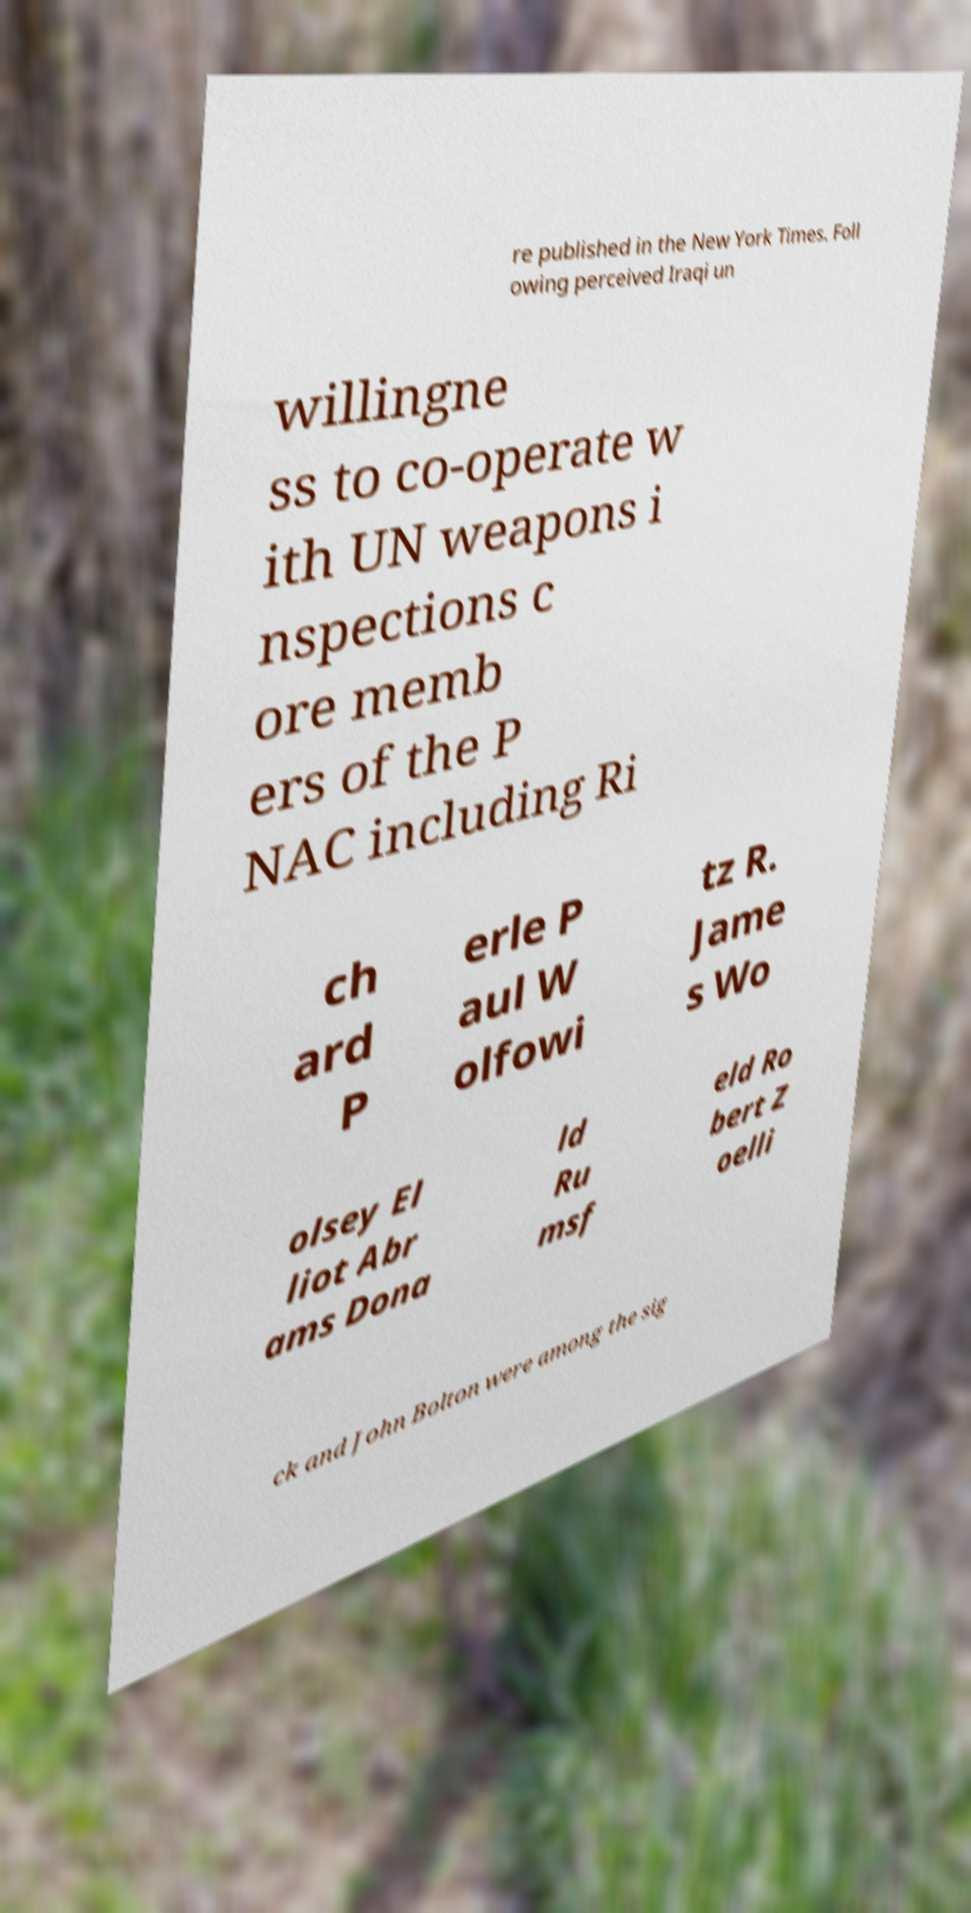Please identify and transcribe the text found in this image. re published in the New York Times. Foll owing perceived Iraqi un willingne ss to co-operate w ith UN weapons i nspections c ore memb ers of the P NAC including Ri ch ard P erle P aul W olfowi tz R. Jame s Wo olsey El liot Abr ams Dona ld Ru msf eld Ro bert Z oelli ck and John Bolton were among the sig 